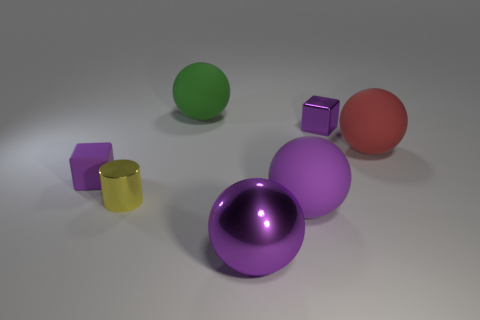Subtract 2 spheres. How many spheres are left? 2 Add 3 tiny purple blocks. How many objects exist? 10 Subtract all green balls. How many balls are left? 3 Subtract all metal spheres. How many spheres are left? 3 Subtract 0 cyan balls. How many objects are left? 7 Subtract all cylinders. How many objects are left? 6 Subtract all gray blocks. Subtract all red spheres. How many blocks are left? 2 Subtract all green balls. How many blue cylinders are left? 0 Subtract all large green spheres. Subtract all large shiny balls. How many objects are left? 5 Add 7 small purple metallic blocks. How many small purple metallic blocks are left? 8 